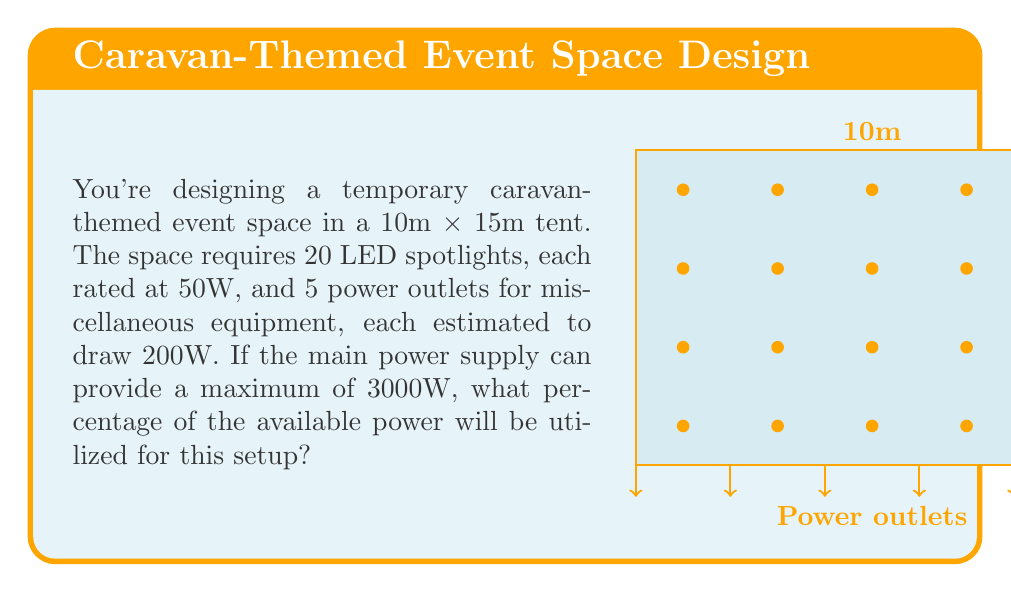Can you solve this math problem? Let's break this down step-by-step:

1) Calculate the total power consumption of the LED spotlights:
   $20 \text{ spotlights} \times 50\text{W} = 1000\text{W}$

2) Calculate the total power consumption of the power outlets:
   $5 \text{ outlets} \times 200\text{W} = 1000\text{W}$

3) Sum up the total power consumption:
   $\text{Total consumption} = 1000\text{W (spotlights)} + 1000\text{W (outlets)} = 2000\text{W}$

4) Calculate the percentage of available power utilized:
   $$\text{Percentage utilized} = \frac{\text{Total consumption}}{\text{Available power}} \times 100\%$$
   $$= \frac{2000\text{W}}{3000\text{W}} \times 100\% = \frac{2}{3} \times 100\% = 66.67\%$$

Therefore, approximately 66.67% of the available power will be utilized for this setup.
Answer: 66.67% 